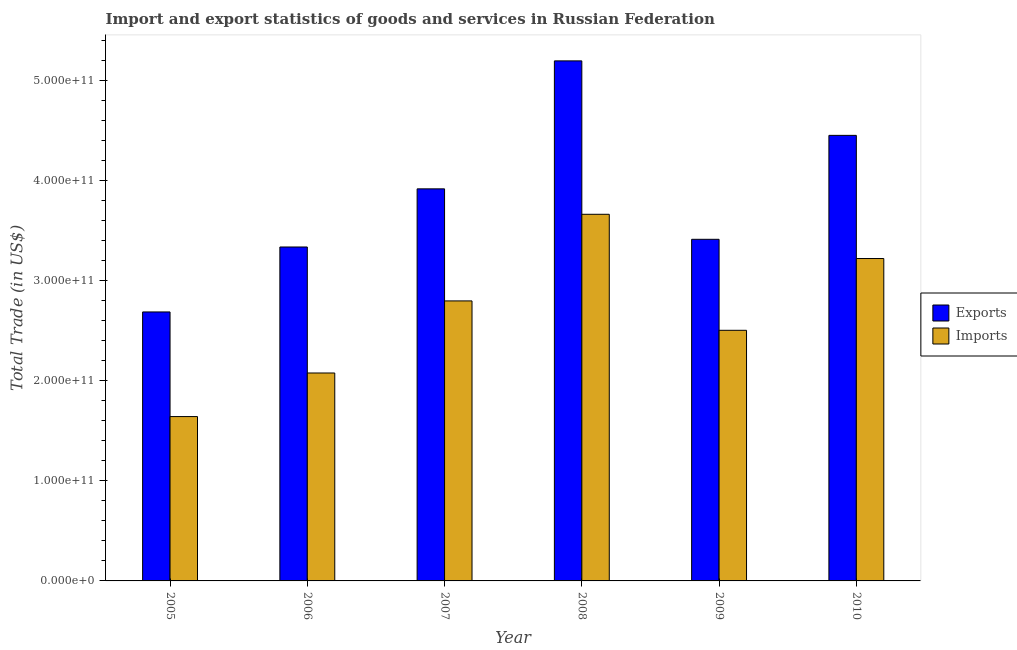How many different coloured bars are there?
Your answer should be compact. 2. Are the number of bars on each tick of the X-axis equal?
Give a very brief answer. Yes. What is the label of the 5th group of bars from the left?
Ensure brevity in your answer.  2009. What is the imports of goods and services in 2005?
Ensure brevity in your answer.  1.64e+11. Across all years, what is the maximum imports of goods and services?
Your answer should be very brief. 3.67e+11. Across all years, what is the minimum imports of goods and services?
Provide a short and direct response. 1.64e+11. In which year was the imports of goods and services maximum?
Ensure brevity in your answer.  2008. What is the total export of goods and services in the graph?
Ensure brevity in your answer.  2.30e+12. What is the difference between the imports of goods and services in 2006 and that in 2008?
Offer a very short reply. -1.59e+11. What is the difference between the export of goods and services in 2009 and the imports of goods and services in 2008?
Ensure brevity in your answer.  -1.78e+11. What is the average imports of goods and services per year?
Keep it short and to the point. 2.65e+11. What is the ratio of the imports of goods and services in 2005 to that in 2009?
Ensure brevity in your answer.  0.66. Is the imports of goods and services in 2007 less than that in 2008?
Your response must be concise. Yes. Is the difference between the export of goods and services in 2007 and 2010 greater than the difference between the imports of goods and services in 2007 and 2010?
Your answer should be compact. No. What is the difference between the highest and the second highest imports of goods and services?
Your response must be concise. 4.42e+1. What is the difference between the highest and the lowest export of goods and services?
Provide a succinct answer. 2.51e+11. In how many years, is the export of goods and services greater than the average export of goods and services taken over all years?
Your answer should be compact. 3. What does the 2nd bar from the left in 2010 represents?
Make the answer very short. Imports. What does the 2nd bar from the right in 2010 represents?
Keep it short and to the point. Exports. Are all the bars in the graph horizontal?
Your response must be concise. No. What is the difference between two consecutive major ticks on the Y-axis?
Make the answer very short. 1.00e+11. Does the graph contain any zero values?
Give a very brief answer. No. Where does the legend appear in the graph?
Make the answer very short. Center right. How are the legend labels stacked?
Provide a succinct answer. Vertical. What is the title of the graph?
Offer a very short reply. Import and export statistics of goods and services in Russian Federation. What is the label or title of the Y-axis?
Ensure brevity in your answer.  Total Trade (in US$). What is the Total Trade (in US$) in Exports in 2005?
Your response must be concise. 2.69e+11. What is the Total Trade (in US$) in Imports in 2005?
Your answer should be very brief. 1.64e+11. What is the Total Trade (in US$) of Exports in 2006?
Your answer should be very brief. 3.34e+11. What is the Total Trade (in US$) in Imports in 2006?
Your response must be concise. 2.08e+11. What is the Total Trade (in US$) of Exports in 2007?
Give a very brief answer. 3.92e+11. What is the Total Trade (in US$) of Imports in 2007?
Provide a short and direct response. 2.80e+11. What is the Total Trade (in US$) of Exports in 2008?
Provide a short and direct response. 5.20e+11. What is the Total Trade (in US$) in Imports in 2008?
Make the answer very short. 3.67e+11. What is the Total Trade (in US$) in Exports in 2009?
Provide a short and direct response. 3.42e+11. What is the Total Trade (in US$) of Imports in 2009?
Offer a very short reply. 2.51e+11. What is the Total Trade (in US$) of Exports in 2010?
Offer a very short reply. 4.46e+11. What is the Total Trade (in US$) of Imports in 2010?
Make the answer very short. 3.22e+11. Across all years, what is the maximum Total Trade (in US$) in Exports?
Offer a terse response. 5.20e+11. Across all years, what is the maximum Total Trade (in US$) in Imports?
Ensure brevity in your answer.  3.67e+11. Across all years, what is the minimum Total Trade (in US$) of Exports?
Your response must be concise. 2.69e+11. Across all years, what is the minimum Total Trade (in US$) of Imports?
Provide a succinct answer. 1.64e+11. What is the total Total Trade (in US$) of Exports in the graph?
Offer a very short reply. 2.30e+12. What is the total Total Trade (in US$) of Imports in the graph?
Your answer should be very brief. 1.59e+12. What is the difference between the Total Trade (in US$) in Exports in 2005 and that in 2006?
Keep it short and to the point. -6.50e+1. What is the difference between the Total Trade (in US$) of Imports in 2005 and that in 2006?
Offer a terse response. -4.36e+1. What is the difference between the Total Trade (in US$) of Exports in 2005 and that in 2007?
Offer a very short reply. -1.23e+11. What is the difference between the Total Trade (in US$) in Imports in 2005 and that in 2007?
Provide a short and direct response. -1.16e+11. What is the difference between the Total Trade (in US$) of Exports in 2005 and that in 2008?
Provide a succinct answer. -2.51e+11. What is the difference between the Total Trade (in US$) of Imports in 2005 and that in 2008?
Offer a terse response. -2.02e+11. What is the difference between the Total Trade (in US$) in Exports in 2005 and that in 2009?
Ensure brevity in your answer.  -7.26e+1. What is the difference between the Total Trade (in US$) in Imports in 2005 and that in 2009?
Your answer should be compact. -8.63e+1. What is the difference between the Total Trade (in US$) in Exports in 2005 and that in 2010?
Provide a succinct answer. -1.77e+11. What is the difference between the Total Trade (in US$) in Imports in 2005 and that in 2010?
Ensure brevity in your answer.  -1.58e+11. What is the difference between the Total Trade (in US$) in Exports in 2006 and that in 2007?
Your answer should be compact. -5.81e+1. What is the difference between the Total Trade (in US$) of Imports in 2006 and that in 2007?
Offer a very short reply. -7.21e+1. What is the difference between the Total Trade (in US$) of Exports in 2006 and that in 2008?
Ensure brevity in your answer.  -1.86e+11. What is the difference between the Total Trade (in US$) of Imports in 2006 and that in 2008?
Provide a short and direct response. -1.59e+11. What is the difference between the Total Trade (in US$) in Exports in 2006 and that in 2009?
Offer a terse response. -7.68e+09. What is the difference between the Total Trade (in US$) in Imports in 2006 and that in 2009?
Your answer should be compact. -4.27e+1. What is the difference between the Total Trade (in US$) of Exports in 2006 and that in 2010?
Make the answer very short. -1.12e+11. What is the difference between the Total Trade (in US$) of Imports in 2006 and that in 2010?
Offer a very short reply. -1.14e+11. What is the difference between the Total Trade (in US$) in Exports in 2007 and that in 2008?
Ensure brevity in your answer.  -1.28e+11. What is the difference between the Total Trade (in US$) in Imports in 2007 and that in 2008?
Make the answer very short. -8.66e+1. What is the difference between the Total Trade (in US$) of Exports in 2007 and that in 2009?
Your answer should be very brief. 5.05e+1. What is the difference between the Total Trade (in US$) in Imports in 2007 and that in 2009?
Your response must be concise. 2.94e+1. What is the difference between the Total Trade (in US$) of Exports in 2007 and that in 2010?
Make the answer very short. -5.35e+1. What is the difference between the Total Trade (in US$) of Imports in 2007 and that in 2010?
Provide a succinct answer. -4.24e+1. What is the difference between the Total Trade (in US$) in Exports in 2008 and that in 2009?
Offer a terse response. 1.78e+11. What is the difference between the Total Trade (in US$) in Imports in 2008 and that in 2009?
Keep it short and to the point. 1.16e+11. What is the difference between the Total Trade (in US$) in Exports in 2008 and that in 2010?
Ensure brevity in your answer.  7.45e+1. What is the difference between the Total Trade (in US$) of Imports in 2008 and that in 2010?
Give a very brief answer. 4.42e+1. What is the difference between the Total Trade (in US$) in Exports in 2009 and that in 2010?
Make the answer very short. -1.04e+11. What is the difference between the Total Trade (in US$) of Imports in 2009 and that in 2010?
Provide a short and direct response. -7.18e+1. What is the difference between the Total Trade (in US$) in Exports in 2005 and the Total Trade (in US$) in Imports in 2006?
Your response must be concise. 6.10e+1. What is the difference between the Total Trade (in US$) of Exports in 2005 and the Total Trade (in US$) of Imports in 2007?
Provide a short and direct response. -1.10e+1. What is the difference between the Total Trade (in US$) in Exports in 2005 and the Total Trade (in US$) in Imports in 2008?
Offer a terse response. -9.76e+1. What is the difference between the Total Trade (in US$) of Exports in 2005 and the Total Trade (in US$) of Imports in 2009?
Ensure brevity in your answer.  1.84e+1. What is the difference between the Total Trade (in US$) of Exports in 2005 and the Total Trade (in US$) of Imports in 2010?
Offer a terse response. -5.34e+1. What is the difference between the Total Trade (in US$) in Exports in 2006 and the Total Trade (in US$) in Imports in 2007?
Your answer should be very brief. 5.39e+1. What is the difference between the Total Trade (in US$) in Exports in 2006 and the Total Trade (in US$) in Imports in 2008?
Provide a succinct answer. -3.27e+1. What is the difference between the Total Trade (in US$) of Exports in 2006 and the Total Trade (in US$) of Imports in 2009?
Make the answer very short. 8.33e+1. What is the difference between the Total Trade (in US$) of Exports in 2006 and the Total Trade (in US$) of Imports in 2010?
Your answer should be very brief. 1.15e+1. What is the difference between the Total Trade (in US$) in Exports in 2007 and the Total Trade (in US$) in Imports in 2008?
Make the answer very short. 2.54e+1. What is the difference between the Total Trade (in US$) of Exports in 2007 and the Total Trade (in US$) of Imports in 2009?
Your response must be concise. 1.41e+11. What is the difference between the Total Trade (in US$) in Exports in 2007 and the Total Trade (in US$) in Imports in 2010?
Your answer should be compact. 6.97e+1. What is the difference between the Total Trade (in US$) of Exports in 2008 and the Total Trade (in US$) of Imports in 2009?
Keep it short and to the point. 2.69e+11. What is the difference between the Total Trade (in US$) of Exports in 2008 and the Total Trade (in US$) of Imports in 2010?
Your response must be concise. 1.98e+11. What is the difference between the Total Trade (in US$) in Exports in 2009 and the Total Trade (in US$) in Imports in 2010?
Your response must be concise. 1.92e+1. What is the average Total Trade (in US$) of Exports per year?
Provide a short and direct response. 3.84e+11. What is the average Total Trade (in US$) in Imports per year?
Provide a short and direct response. 2.65e+11. In the year 2005, what is the difference between the Total Trade (in US$) in Exports and Total Trade (in US$) in Imports?
Your answer should be compact. 1.05e+11. In the year 2006, what is the difference between the Total Trade (in US$) in Exports and Total Trade (in US$) in Imports?
Provide a succinct answer. 1.26e+11. In the year 2007, what is the difference between the Total Trade (in US$) of Exports and Total Trade (in US$) of Imports?
Give a very brief answer. 1.12e+11. In the year 2008, what is the difference between the Total Trade (in US$) of Exports and Total Trade (in US$) of Imports?
Offer a terse response. 1.53e+11. In the year 2009, what is the difference between the Total Trade (in US$) in Exports and Total Trade (in US$) in Imports?
Provide a short and direct response. 9.10e+1. In the year 2010, what is the difference between the Total Trade (in US$) of Exports and Total Trade (in US$) of Imports?
Offer a terse response. 1.23e+11. What is the ratio of the Total Trade (in US$) of Exports in 2005 to that in 2006?
Ensure brevity in your answer.  0.81. What is the ratio of the Total Trade (in US$) in Imports in 2005 to that in 2006?
Offer a very short reply. 0.79. What is the ratio of the Total Trade (in US$) in Exports in 2005 to that in 2007?
Your answer should be compact. 0.69. What is the ratio of the Total Trade (in US$) of Imports in 2005 to that in 2007?
Offer a very short reply. 0.59. What is the ratio of the Total Trade (in US$) in Exports in 2005 to that in 2008?
Keep it short and to the point. 0.52. What is the ratio of the Total Trade (in US$) in Imports in 2005 to that in 2008?
Your answer should be very brief. 0.45. What is the ratio of the Total Trade (in US$) in Exports in 2005 to that in 2009?
Provide a short and direct response. 0.79. What is the ratio of the Total Trade (in US$) of Imports in 2005 to that in 2009?
Provide a succinct answer. 0.66. What is the ratio of the Total Trade (in US$) of Exports in 2005 to that in 2010?
Provide a short and direct response. 0.6. What is the ratio of the Total Trade (in US$) in Imports in 2005 to that in 2010?
Keep it short and to the point. 0.51. What is the ratio of the Total Trade (in US$) in Exports in 2006 to that in 2007?
Offer a terse response. 0.85. What is the ratio of the Total Trade (in US$) of Imports in 2006 to that in 2007?
Give a very brief answer. 0.74. What is the ratio of the Total Trade (in US$) of Exports in 2006 to that in 2008?
Ensure brevity in your answer.  0.64. What is the ratio of the Total Trade (in US$) of Imports in 2006 to that in 2008?
Ensure brevity in your answer.  0.57. What is the ratio of the Total Trade (in US$) in Exports in 2006 to that in 2009?
Ensure brevity in your answer.  0.98. What is the ratio of the Total Trade (in US$) of Imports in 2006 to that in 2009?
Your answer should be very brief. 0.83. What is the ratio of the Total Trade (in US$) of Exports in 2006 to that in 2010?
Offer a terse response. 0.75. What is the ratio of the Total Trade (in US$) in Imports in 2006 to that in 2010?
Ensure brevity in your answer.  0.65. What is the ratio of the Total Trade (in US$) in Exports in 2007 to that in 2008?
Offer a terse response. 0.75. What is the ratio of the Total Trade (in US$) in Imports in 2007 to that in 2008?
Give a very brief answer. 0.76. What is the ratio of the Total Trade (in US$) in Exports in 2007 to that in 2009?
Make the answer very short. 1.15. What is the ratio of the Total Trade (in US$) in Imports in 2007 to that in 2009?
Ensure brevity in your answer.  1.12. What is the ratio of the Total Trade (in US$) in Imports in 2007 to that in 2010?
Your answer should be very brief. 0.87. What is the ratio of the Total Trade (in US$) of Exports in 2008 to that in 2009?
Your answer should be very brief. 1.52. What is the ratio of the Total Trade (in US$) in Imports in 2008 to that in 2009?
Your answer should be very brief. 1.46. What is the ratio of the Total Trade (in US$) of Exports in 2008 to that in 2010?
Make the answer very short. 1.17. What is the ratio of the Total Trade (in US$) in Imports in 2008 to that in 2010?
Your response must be concise. 1.14. What is the ratio of the Total Trade (in US$) in Exports in 2009 to that in 2010?
Keep it short and to the point. 0.77. What is the ratio of the Total Trade (in US$) in Imports in 2009 to that in 2010?
Your answer should be very brief. 0.78. What is the difference between the highest and the second highest Total Trade (in US$) of Exports?
Make the answer very short. 7.45e+1. What is the difference between the highest and the second highest Total Trade (in US$) in Imports?
Offer a very short reply. 4.42e+1. What is the difference between the highest and the lowest Total Trade (in US$) of Exports?
Provide a succinct answer. 2.51e+11. What is the difference between the highest and the lowest Total Trade (in US$) of Imports?
Ensure brevity in your answer.  2.02e+11. 